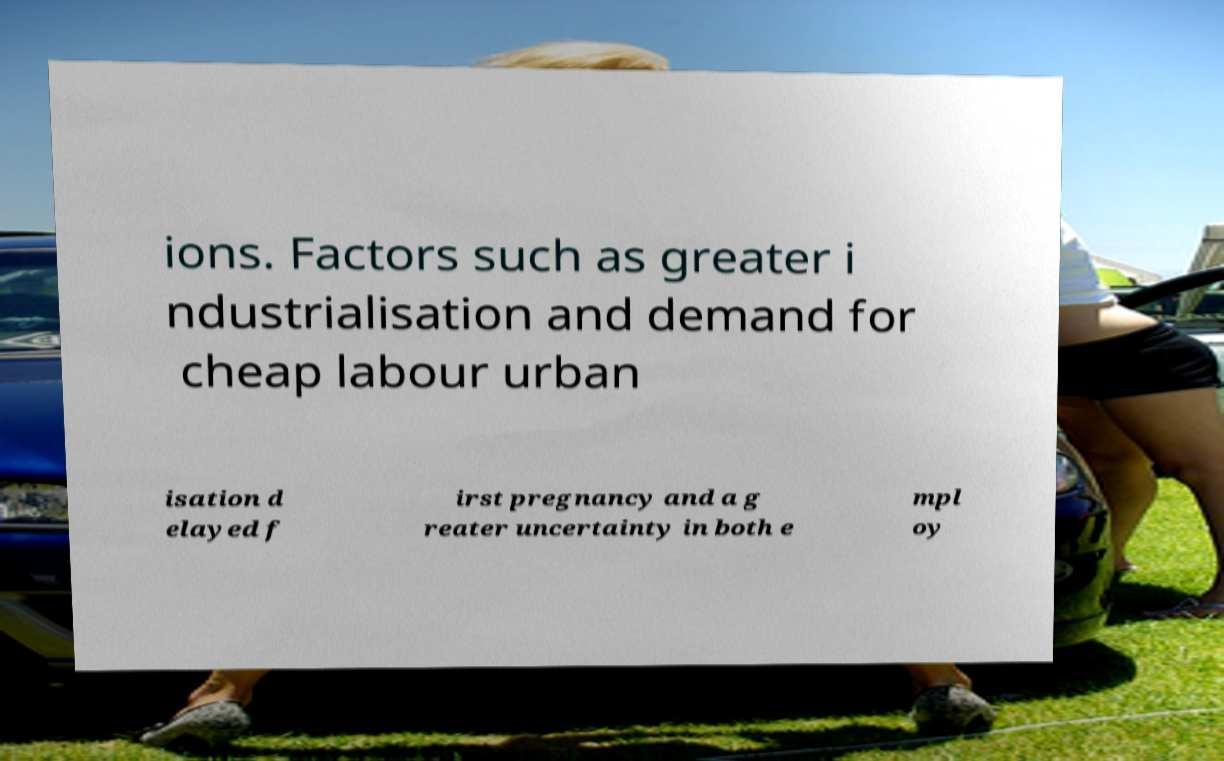Please read and relay the text visible in this image. What does it say? ions. Factors such as greater i ndustrialisation and demand for cheap labour urban isation d elayed f irst pregnancy and a g reater uncertainty in both e mpl oy 